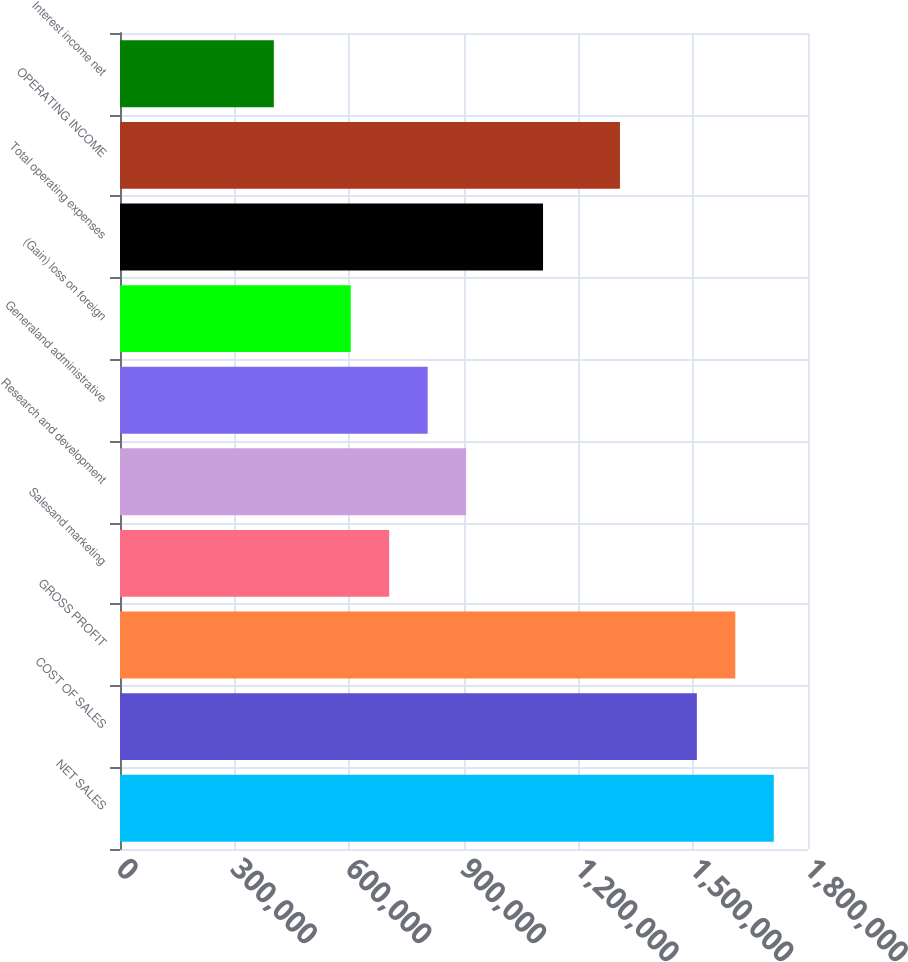<chart> <loc_0><loc_0><loc_500><loc_500><bar_chart><fcel>NET SALES<fcel>COST OF SALES<fcel>GROSS PROFIT<fcel>Salesand marketing<fcel>Research and development<fcel>Generaland administrative<fcel>(Gain) loss on foreign<fcel>Total operating expenses<fcel>OPERATING INCOME<fcel>Interest income net<nl><fcel>1.71049e+06<fcel>1.50926e+06<fcel>1.60987e+06<fcel>704323<fcel>905556<fcel>804939<fcel>603706<fcel>1.10679e+06<fcel>1.30802e+06<fcel>402472<nl></chart> 